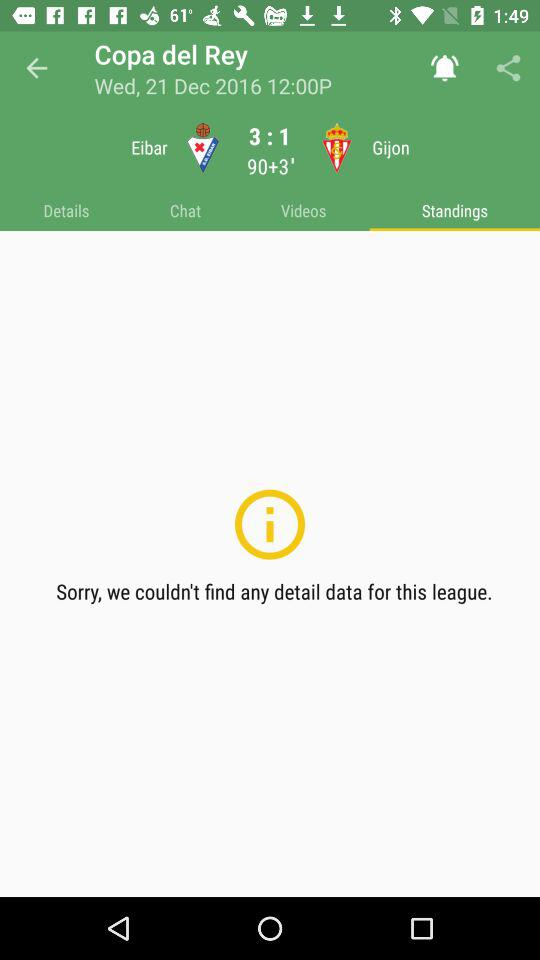How many more goals has Bayern Munich scored than Hertha Berlin?
Answer the question using a single word or phrase. 3 